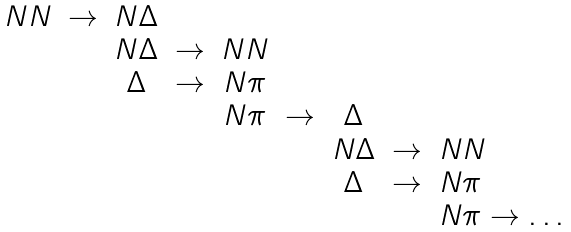Convert formula to latex. <formula><loc_0><loc_0><loc_500><loc_500>\begin{array} { r c c c c c c c l } N N & \to & N \Delta & & & & & & \\ & & N \Delta & \to & N N & & & & \\ & & \Delta & \to & N \pi & & & & \\ & & & & N \pi & \to & \Delta & & \\ & & & & & & N \Delta & \to & N N \\ & & & & & & \Delta & \to & N \pi \\ & & & & & & & & N \pi \to \dots \\ \end{array}</formula> 